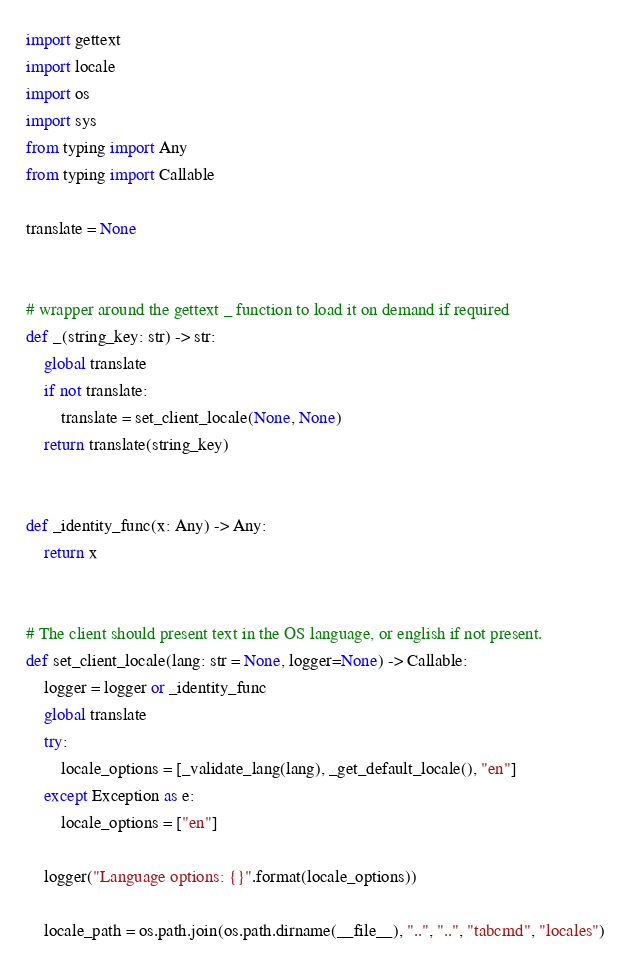<code> <loc_0><loc_0><loc_500><loc_500><_Python_>import gettext
import locale
import os
import sys
from typing import Any
from typing import Callable

translate = None


# wrapper around the gettext _ function to load it on demand if required
def _(string_key: str) -> str:
    global translate
    if not translate:
        translate = set_client_locale(None, None)
    return translate(string_key)


def _identity_func(x: Any) -> Any:
    return x


# The client should present text in the OS language, or english if not present.
def set_client_locale(lang: str = None, logger=None) -> Callable:
    logger = logger or _identity_func
    global translate
    try:
        locale_options = [_validate_lang(lang), _get_default_locale(), "en"]
    except Exception as e:
        locale_options = ["en"]

    logger("Language options: {}".format(locale_options))

    locale_path = os.path.join(os.path.dirname(__file__), "..", "..", "tabcmd", "locales")</code> 